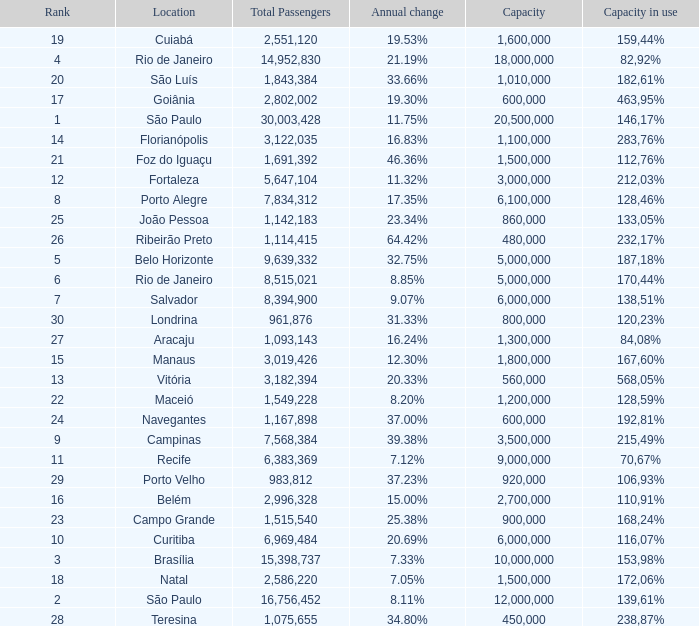Which location has a capacity that has a rank of 23? 168,24%. 